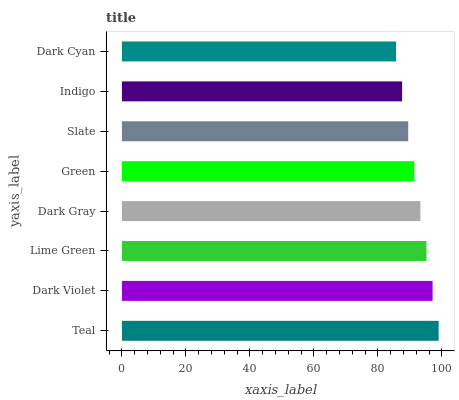Is Dark Cyan the minimum?
Answer yes or no. Yes. Is Teal the maximum?
Answer yes or no. Yes. Is Dark Violet the minimum?
Answer yes or no. No. Is Dark Violet the maximum?
Answer yes or no. No. Is Teal greater than Dark Violet?
Answer yes or no. Yes. Is Dark Violet less than Teal?
Answer yes or no. Yes. Is Dark Violet greater than Teal?
Answer yes or no. No. Is Teal less than Dark Violet?
Answer yes or no. No. Is Dark Gray the high median?
Answer yes or no. Yes. Is Green the low median?
Answer yes or no. Yes. Is Slate the high median?
Answer yes or no. No. Is Dark Violet the low median?
Answer yes or no. No. 